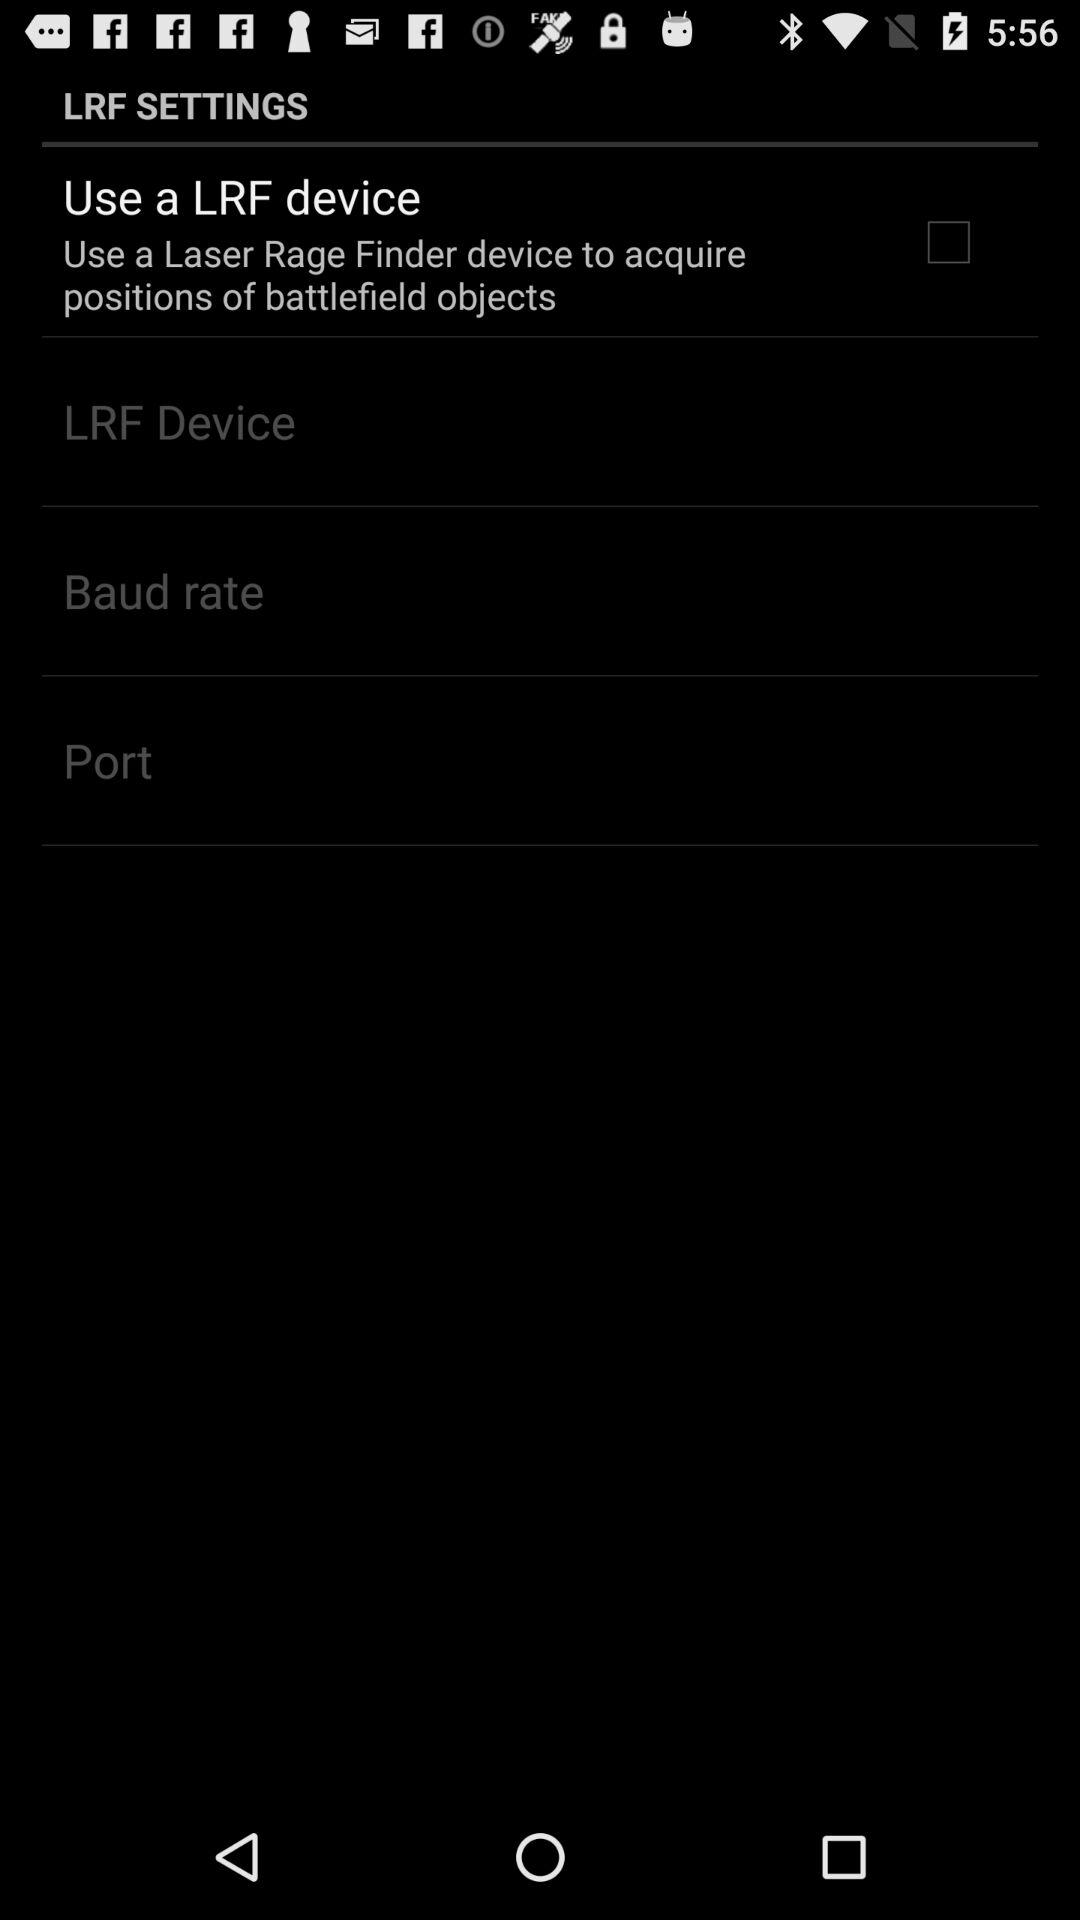What is the status of "Use a LRF device"? The status is "off". 